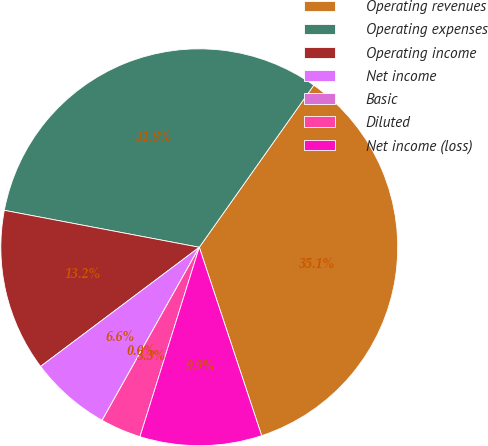Convert chart to OTSL. <chart><loc_0><loc_0><loc_500><loc_500><pie_chart><fcel>Operating revenues<fcel>Operating expenses<fcel>Operating income<fcel>Net income<fcel>Basic<fcel>Diluted<fcel>Net income (loss)<nl><fcel>35.12%<fcel>31.81%<fcel>13.23%<fcel>6.61%<fcel>0.0%<fcel>3.31%<fcel>9.92%<nl></chart> 